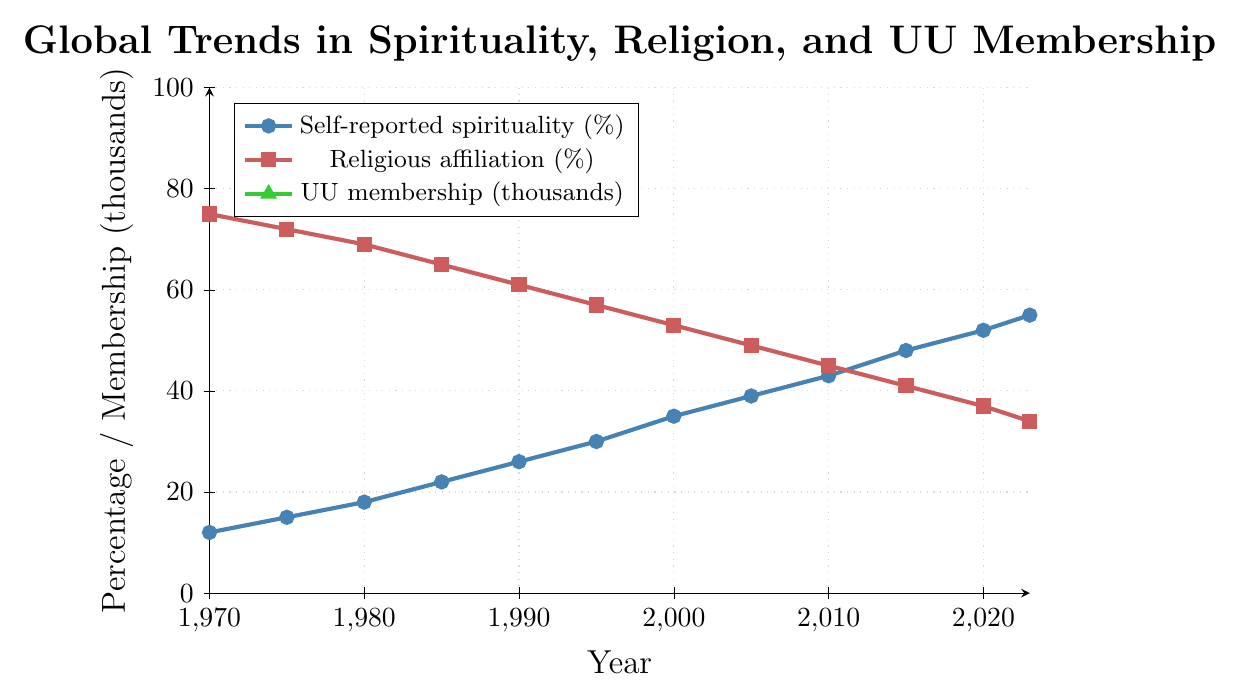What is the trend in self-reported spirituality from 1970 to 2023? The line for self-reported spirituality shows a steady increase from 12% in 1970 to 55% in 2023.
Answer: Steady increase What was the percentage of religious affiliation in 1990? From the figure, the data point for religious affiliation in 1990 is marked and plotted on the graph, showing 61%.
Answer: 61% How does UU membership compare to religious affiliation in terms of trend? UU membership shows a gradual decrease over time, from 180 thousand in 1970 to 138 thousand in 2023, whereas religious affiliation also decreases from 75% in 1970 to 34% in 2023 but at a different initial magnitude.
Answer: Both decrease over time What can be observed about the rate of increase in self-reported spirituality from 1970 to 2000 compared to 2000 to 2023? From 1970 to 2000, self-reported spirituality increased from 12% to 35%, a total of 23% over 30 years. From 2000 to 2023, it increased from 35% to 55%, a total of 20% over 23 years, showing almost similar rates of increase when normalized by time.
Answer: Similar rates of increase When did self-reported spirituality surpass 40%? From the chart, self-reported spirituality surpasses 40% between 2010 (43%) and 2015 (48%).
Answer: Between 2010 and 2015 Compare the self-reported spirituality in 1980 and 2005. In 1980, self-reported spirituality was 18%, while in 2005 it increased to 39%.
Answer: 18% in 1980, 39% in 2005 By how much did religious affiliation decrease from 1970 to 2023? Religious affiliation decreased from 75% in 1970 to 34% in 2023, a total decrease of 75% - 34% = 41%.
Answer: 41% What is the difference between UU membership in 1970 and 2023? UU membership decreased from 180 thousand in 1970 to 138 thousand in 2023, a difference of 180 - 138 = 42 thousand.
Answer: 42 thousand Which year had the highest rate of increase in self-reported spirituality? The greatest rate of increase can be observed by comparing the slopes of line segments; examining the data provided: from 2000 to 2005 (5 years), self-reported spirituality increased from 35% to 39%, an increase of 4% in 5 years, which seems highest among all intervals.
Answer: 2000 to 2005 